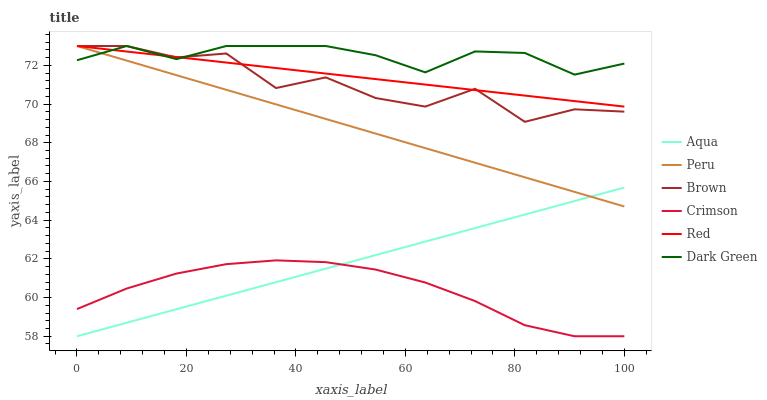Does Crimson have the minimum area under the curve?
Answer yes or no. Yes. Does Dark Green have the maximum area under the curve?
Answer yes or no. Yes. Does Aqua have the minimum area under the curve?
Answer yes or no. No. Does Aqua have the maximum area under the curve?
Answer yes or no. No. Is Red the smoothest?
Answer yes or no. Yes. Is Brown the roughest?
Answer yes or no. Yes. Is Aqua the smoothest?
Answer yes or no. No. Is Aqua the roughest?
Answer yes or no. No. Does Peru have the lowest value?
Answer yes or no. No. Does Dark Green have the highest value?
Answer yes or no. Yes. Does Aqua have the highest value?
Answer yes or no. No. Is Aqua less than Dark Green?
Answer yes or no. Yes. Is Dark Green greater than Crimson?
Answer yes or no. Yes. Does Red intersect Peru?
Answer yes or no. Yes. Is Red less than Peru?
Answer yes or no. No. Is Red greater than Peru?
Answer yes or no. No. Does Aqua intersect Dark Green?
Answer yes or no. No. 